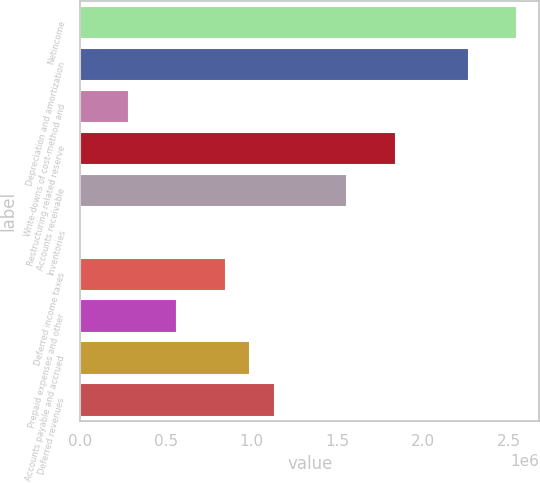<chart> <loc_0><loc_0><loc_500><loc_500><bar_chart><fcel>Netincome<fcel>Depreciation and amortization<fcel>Write-downs of cost-method and<fcel>Restructuring related reserve<fcel>Accounts receivable<fcel>Inventories<fcel>Deferred income taxes<fcel>Prepaid expenses and other<fcel>Accounts payable and accrued<fcel>Deferred revenues<nl><fcel>2.54901e+06<fcel>2.26582e+06<fcel>283540<fcel>1.84105e+06<fcel>1.55787e+06<fcel>357<fcel>849907<fcel>566724<fcel>991499<fcel>1.13309e+06<nl></chart> 